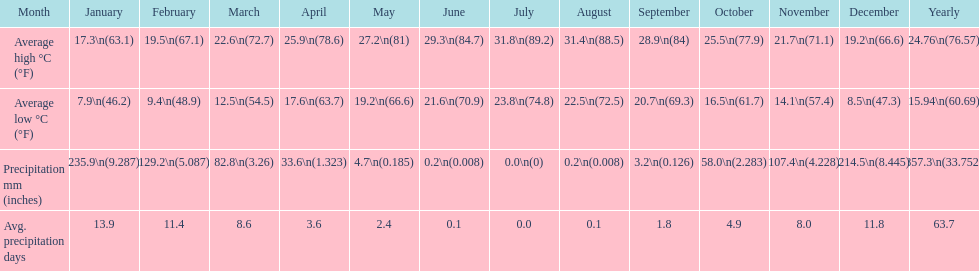What is the month with the lowest average low in haifa? January. 